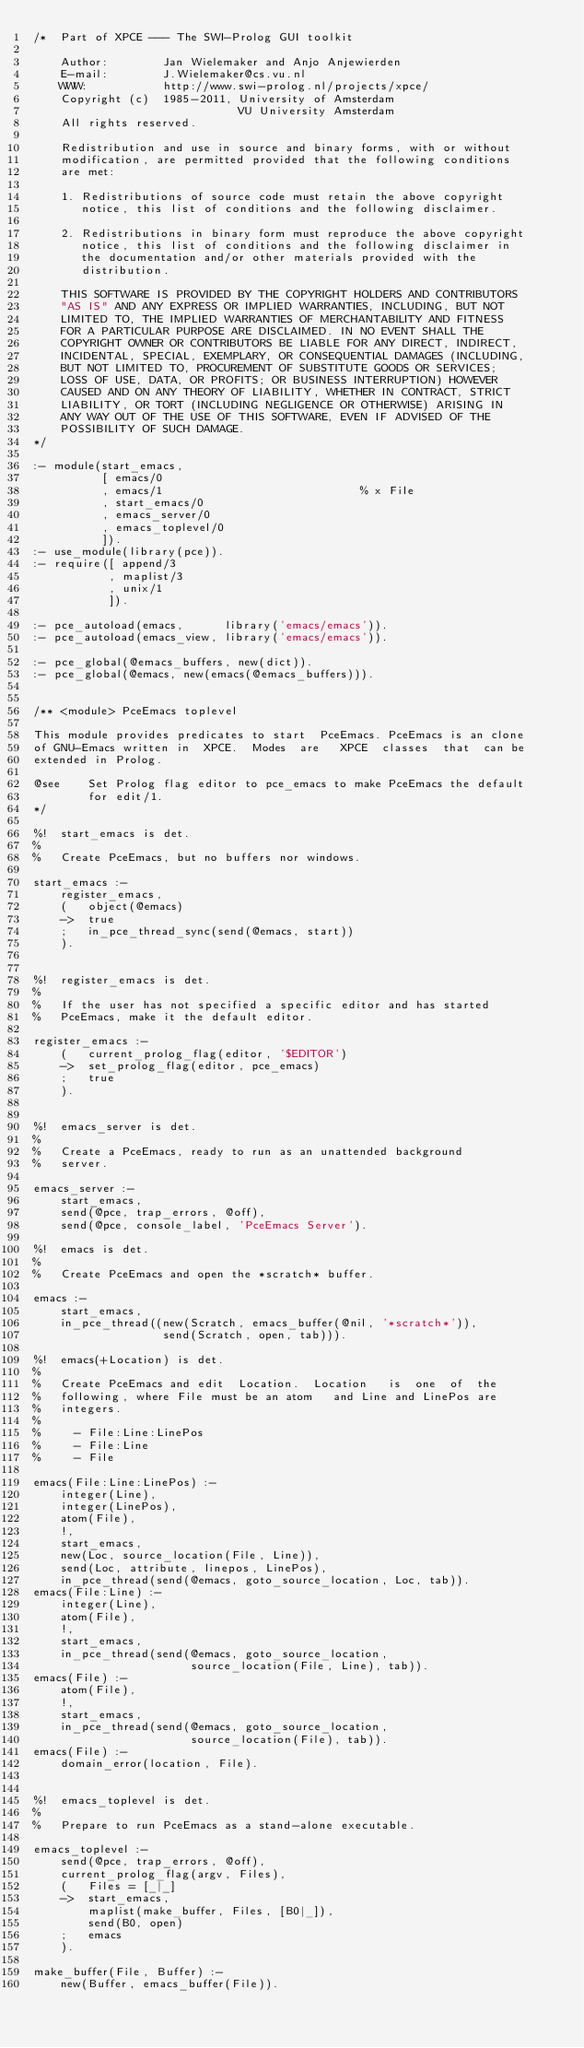Convert code to text. <code><loc_0><loc_0><loc_500><loc_500><_Perl_>/*  Part of XPCE --- The SWI-Prolog GUI toolkit

    Author:        Jan Wielemaker and Anjo Anjewierden
    E-mail:        J.Wielemaker@cs.vu.nl
    WWW:           http://www.swi-prolog.nl/projects/xpce/
    Copyright (c)  1985-2011, University of Amsterdam
                              VU University Amsterdam
    All rights reserved.

    Redistribution and use in source and binary forms, with or without
    modification, are permitted provided that the following conditions
    are met:

    1. Redistributions of source code must retain the above copyright
       notice, this list of conditions and the following disclaimer.

    2. Redistributions in binary form must reproduce the above copyright
       notice, this list of conditions and the following disclaimer in
       the documentation and/or other materials provided with the
       distribution.

    THIS SOFTWARE IS PROVIDED BY THE COPYRIGHT HOLDERS AND CONTRIBUTORS
    "AS IS" AND ANY EXPRESS OR IMPLIED WARRANTIES, INCLUDING, BUT NOT
    LIMITED TO, THE IMPLIED WARRANTIES OF MERCHANTABILITY AND FITNESS
    FOR A PARTICULAR PURPOSE ARE DISCLAIMED. IN NO EVENT SHALL THE
    COPYRIGHT OWNER OR CONTRIBUTORS BE LIABLE FOR ANY DIRECT, INDIRECT,
    INCIDENTAL, SPECIAL, EXEMPLARY, OR CONSEQUENTIAL DAMAGES (INCLUDING,
    BUT NOT LIMITED TO, PROCUREMENT OF SUBSTITUTE GOODS OR SERVICES;
    LOSS OF USE, DATA, OR PROFITS; OR BUSINESS INTERRUPTION) HOWEVER
    CAUSED AND ON ANY THEORY OF LIABILITY, WHETHER IN CONTRACT, STRICT
    LIABILITY, OR TORT (INCLUDING NEGLIGENCE OR OTHERWISE) ARISING IN
    ANY WAY OUT OF THE USE OF THIS SOFTWARE, EVEN IF ADVISED OF THE
    POSSIBILITY OF SUCH DAMAGE.
*/

:- module(start_emacs,
          [ emacs/0
          , emacs/1                             % x File
          , start_emacs/0
          , emacs_server/0
          , emacs_toplevel/0
          ]).
:- use_module(library(pce)).
:- require([ append/3
           , maplist/3
           , unix/1
           ]).

:- pce_autoload(emacs,      library('emacs/emacs')).
:- pce_autoload(emacs_view, library('emacs/emacs')).

:- pce_global(@emacs_buffers, new(dict)).
:- pce_global(@emacs, new(emacs(@emacs_buffers))).


/** <module> PceEmacs toplevel

This module provides predicates to start  PceEmacs. PceEmacs is an clone
of GNU-Emacs written in  XPCE.  Modes  are   XPCE  classes  that  can be
extended in Prolog.

@see    Set Prolog flag editor to pce_emacs to make PceEmacs the default
        for edit/1.
*/

%!  start_emacs is det.
%
%   Create PceEmacs, but no buffers nor windows.

start_emacs :-
    register_emacs,
    (   object(@emacs)
    ->  true
    ;   in_pce_thread_sync(send(@emacs, start))
    ).


%!  register_emacs is det.
%
%   If the user has not specified a specific editor and has started
%   PceEmacs, make it the default editor.

register_emacs :-
    (   current_prolog_flag(editor, '$EDITOR')
    ->  set_prolog_flag(editor, pce_emacs)
    ;   true
    ).


%!  emacs_server is det.
%
%   Create a PceEmacs, ready to run as an unattended background
%   server.

emacs_server :-
    start_emacs,
    send(@pce, trap_errors, @off),
    send(@pce, console_label, 'PceEmacs Server').

%!  emacs is det.
%
%   Create PceEmacs and open the *scratch* buffer.

emacs :-
    start_emacs,
    in_pce_thread((new(Scratch, emacs_buffer(@nil, '*scratch*')),
                   send(Scratch, open, tab))).

%!  emacs(+Location) is det.
%
%   Create PceEmacs and edit  Location.  Location   is  one  of  the
%   following, where File must be an atom   and Line and LinePos are
%   integers.
%
%     - File:Line:LinePos
%     - File:Line
%     - File

emacs(File:Line:LinePos) :-
    integer(Line),
    integer(LinePos),
    atom(File),
    !,
    start_emacs,
    new(Loc, source_location(File, Line)),
    send(Loc, attribute, linepos, LinePos),
    in_pce_thread(send(@emacs, goto_source_location, Loc, tab)).
emacs(File:Line) :-
    integer(Line),
    atom(File),
    !,
    start_emacs,
    in_pce_thread(send(@emacs, goto_source_location,
                       source_location(File, Line), tab)).
emacs(File) :-
    atom(File),
    !,
    start_emacs,
    in_pce_thread(send(@emacs, goto_source_location,
                       source_location(File), tab)).
emacs(File) :-
    domain_error(location, File).


%!  emacs_toplevel is det.
%
%   Prepare to run PceEmacs as a stand-alone executable.

emacs_toplevel :-
    send(@pce, trap_errors, @off),
    current_prolog_flag(argv, Files),
    (   Files = [_|_]
    ->  start_emacs,
        maplist(make_buffer, Files, [B0|_]),
        send(B0, open)
    ;   emacs
    ).

make_buffer(File, Buffer) :-
    new(Buffer, emacs_buffer(File)).
</code> 